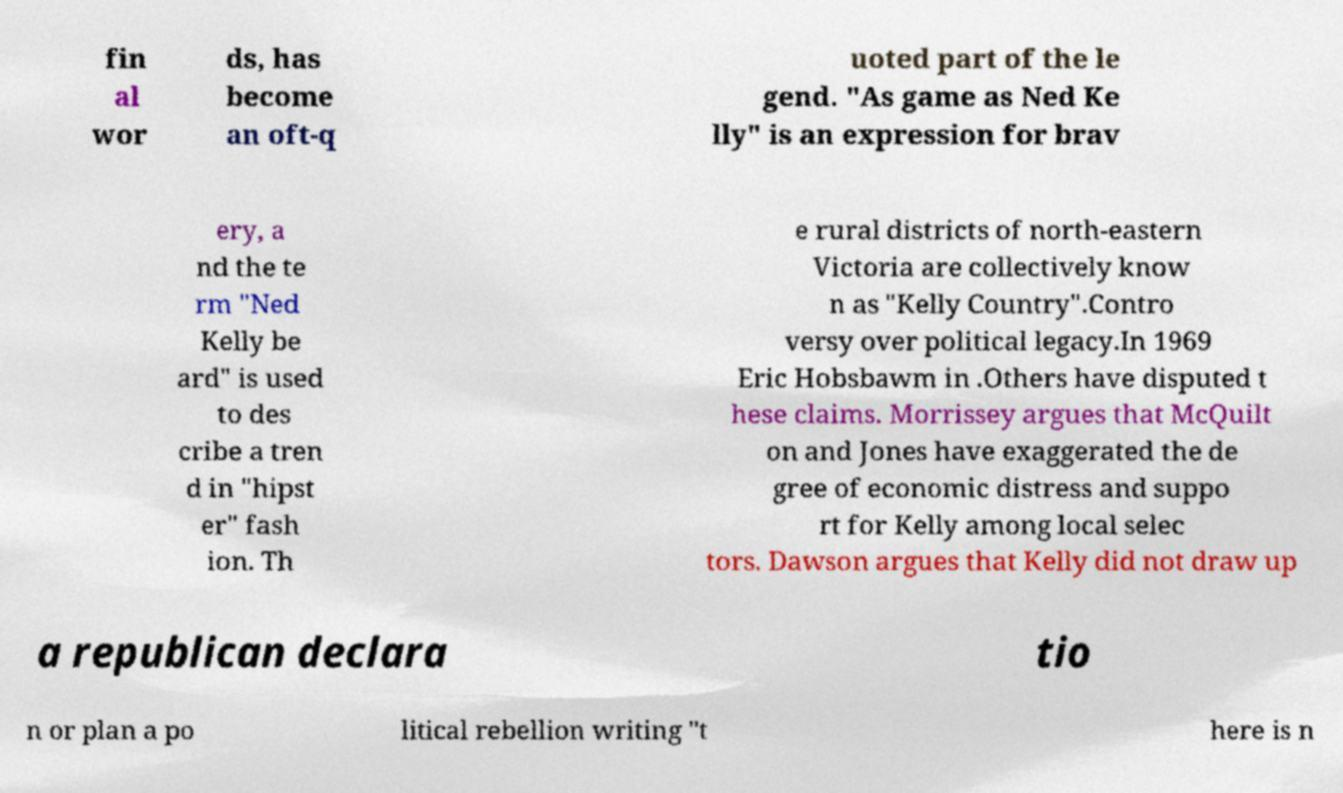There's text embedded in this image that I need extracted. Can you transcribe it verbatim? fin al wor ds, has become an oft-q uoted part of the le gend. "As game as Ned Ke lly" is an expression for brav ery, a nd the te rm "Ned Kelly be ard" is used to des cribe a tren d in "hipst er" fash ion. Th e rural districts of north-eastern Victoria are collectively know n as "Kelly Country".Contro versy over political legacy.In 1969 Eric Hobsbawm in .Others have disputed t hese claims. Morrissey argues that McQuilt on and Jones have exaggerated the de gree of economic distress and suppo rt for Kelly among local selec tors. Dawson argues that Kelly did not draw up a republican declara tio n or plan a po litical rebellion writing "t here is n 